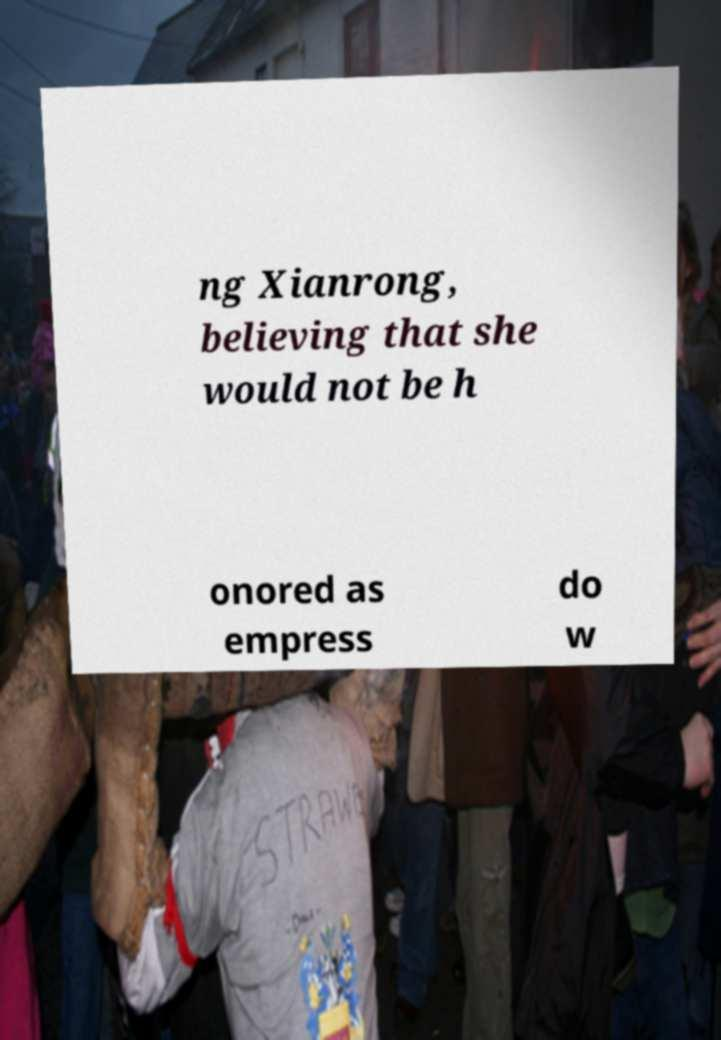Please identify and transcribe the text found in this image. ng Xianrong, believing that she would not be h onored as empress do w 